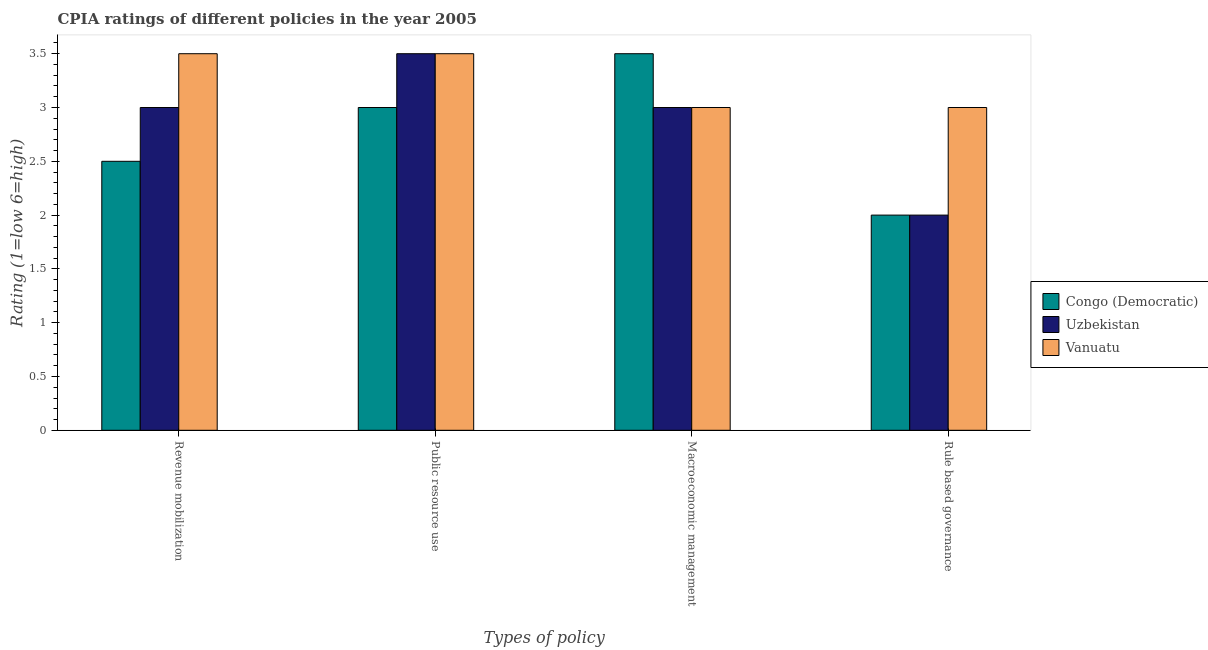Are the number of bars on each tick of the X-axis equal?
Give a very brief answer. Yes. How many bars are there on the 2nd tick from the right?
Your answer should be very brief. 3. What is the label of the 3rd group of bars from the left?
Ensure brevity in your answer.  Macroeconomic management. What is the cpia rating of revenue mobilization in Congo (Democratic)?
Keep it short and to the point. 2.5. Across all countries, what is the minimum cpia rating of revenue mobilization?
Your answer should be very brief. 2.5. In which country was the cpia rating of public resource use maximum?
Provide a short and direct response. Uzbekistan. In which country was the cpia rating of public resource use minimum?
Give a very brief answer. Congo (Democratic). What is the difference between the cpia rating of public resource use in Congo (Democratic) and that in Vanuatu?
Your answer should be compact. -0.5. What is the difference between the cpia rating of rule based governance in Vanuatu and the cpia rating of macroeconomic management in Congo (Democratic)?
Your answer should be compact. -0.5. What is the average cpia rating of rule based governance per country?
Ensure brevity in your answer.  2.33. What is the ratio of the cpia rating of rule based governance in Uzbekistan to that in Vanuatu?
Offer a very short reply. 0.67. What is the difference between the highest and the second highest cpia rating of public resource use?
Your response must be concise. 0. What is the difference between the highest and the lowest cpia rating of public resource use?
Offer a terse response. 0.5. In how many countries, is the cpia rating of public resource use greater than the average cpia rating of public resource use taken over all countries?
Offer a very short reply. 2. What does the 2nd bar from the left in Public resource use represents?
Offer a very short reply. Uzbekistan. What does the 1st bar from the right in Rule based governance represents?
Your response must be concise. Vanuatu. How many bars are there?
Offer a terse response. 12. How many countries are there in the graph?
Provide a succinct answer. 3. What is the difference between two consecutive major ticks on the Y-axis?
Your response must be concise. 0.5. Does the graph contain grids?
Give a very brief answer. No. How many legend labels are there?
Ensure brevity in your answer.  3. How are the legend labels stacked?
Offer a very short reply. Vertical. What is the title of the graph?
Give a very brief answer. CPIA ratings of different policies in the year 2005. Does "Czech Republic" appear as one of the legend labels in the graph?
Offer a terse response. No. What is the label or title of the X-axis?
Ensure brevity in your answer.  Types of policy. What is the Rating (1=low 6=high) of Congo (Democratic) in Revenue mobilization?
Your response must be concise. 2.5. What is the Rating (1=low 6=high) in Congo (Democratic) in Public resource use?
Ensure brevity in your answer.  3. What is the Rating (1=low 6=high) in Congo (Democratic) in Macroeconomic management?
Provide a succinct answer. 3.5. What is the Rating (1=low 6=high) of Uzbekistan in Rule based governance?
Give a very brief answer. 2. Across all Types of policy, what is the maximum Rating (1=low 6=high) in Congo (Democratic)?
Make the answer very short. 3.5. Across all Types of policy, what is the maximum Rating (1=low 6=high) in Vanuatu?
Your response must be concise. 3.5. Across all Types of policy, what is the minimum Rating (1=low 6=high) of Congo (Democratic)?
Provide a succinct answer. 2. Across all Types of policy, what is the minimum Rating (1=low 6=high) in Uzbekistan?
Your response must be concise. 2. Across all Types of policy, what is the minimum Rating (1=low 6=high) of Vanuatu?
Provide a short and direct response. 3. What is the difference between the Rating (1=low 6=high) of Congo (Democratic) in Revenue mobilization and that in Public resource use?
Offer a very short reply. -0.5. What is the difference between the Rating (1=low 6=high) of Congo (Democratic) in Revenue mobilization and that in Macroeconomic management?
Offer a very short reply. -1. What is the difference between the Rating (1=low 6=high) of Vanuatu in Revenue mobilization and that in Macroeconomic management?
Offer a very short reply. 0.5. What is the difference between the Rating (1=low 6=high) in Congo (Democratic) in Revenue mobilization and that in Rule based governance?
Provide a short and direct response. 0.5. What is the difference between the Rating (1=low 6=high) of Vanuatu in Revenue mobilization and that in Rule based governance?
Give a very brief answer. 0.5. What is the difference between the Rating (1=low 6=high) of Congo (Democratic) in Public resource use and that in Macroeconomic management?
Provide a short and direct response. -0.5. What is the difference between the Rating (1=low 6=high) of Vanuatu in Public resource use and that in Macroeconomic management?
Your response must be concise. 0.5. What is the difference between the Rating (1=low 6=high) of Congo (Democratic) in Public resource use and that in Rule based governance?
Your answer should be compact. 1. What is the difference between the Rating (1=low 6=high) in Uzbekistan in Public resource use and that in Rule based governance?
Ensure brevity in your answer.  1.5. What is the difference between the Rating (1=low 6=high) in Vanuatu in Public resource use and that in Rule based governance?
Make the answer very short. 0.5. What is the difference between the Rating (1=low 6=high) of Congo (Democratic) in Macroeconomic management and that in Rule based governance?
Your answer should be very brief. 1.5. What is the difference between the Rating (1=low 6=high) of Uzbekistan in Macroeconomic management and that in Rule based governance?
Provide a short and direct response. 1. What is the difference between the Rating (1=low 6=high) in Vanuatu in Macroeconomic management and that in Rule based governance?
Offer a very short reply. 0. What is the difference between the Rating (1=low 6=high) of Uzbekistan in Revenue mobilization and the Rating (1=low 6=high) of Vanuatu in Public resource use?
Make the answer very short. -0.5. What is the difference between the Rating (1=low 6=high) in Congo (Democratic) in Revenue mobilization and the Rating (1=low 6=high) in Uzbekistan in Macroeconomic management?
Ensure brevity in your answer.  -0.5. What is the difference between the Rating (1=low 6=high) in Congo (Democratic) in Revenue mobilization and the Rating (1=low 6=high) in Vanuatu in Macroeconomic management?
Keep it short and to the point. -0.5. What is the difference between the Rating (1=low 6=high) in Uzbekistan in Revenue mobilization and the Rating (1=low 6=high) in Vanuatu in Macroeconomic management?
Provide a short and direct response. 0. What is the difference between the Rating (1=low 6=high) in Congo (Democratic) in Revenue mobilization and the Rating (1=low 6=high) in Uzbekistan in Rule based governance?
Your answer should be very brief. 0.5. What is the difference between the Rating (1=low 6=high) of Congo (Democratic) in Public resource use and the Rating (1=low 6=high) of Uzbekistan in Macroeconomic management?
Your response must be concise. 0. What is the difference between the Rating (1=low 6=high) of Congo (Democratic) in Public resource use and the Rating (1=low 6=high) of Vanuatu in Macroeconomic management?
Provide a succinct answer. 0. What is the average Rating (1=low 6=high) in Congo (Democratic) per Types of policy?
Make the answer very short. 2.75. What is the average Rating (1=low 6=high) of Uzbekistan per Types of policy?
Your answer should be compact. 2.88. What is the difference between the Rating (1=low 6=high) of Congo (Democratic) and Rating (1=low 6=high) of Uzbekistan in Public resource use?
Your response must be concise. -0.5. What is the difference between the Rating (1=low 6=high) of Uzbekistan and Rating (1=low 6=high) of Vanuatu in Public resource use?
Provide a succinct answer. 0. What is the difference between the Rating (1=low 6=high) in Congo (Democratic) and Rating (1=low 6=high) in Uzbekistan in Macroeconomic management?
Provide a short and direct response. 0.5. What is the difference between the Rating (1=low 6=high) of Uzbekistan and Rating (1=low 6=high) of Vanuatu in Macroeconomic management?
Make the answer very short. 0. What is the difference between the Rating (1=low 6=high) in Congo (Democratic) and Rating (1=low 6=high) in Vanuatu in Rule based governance?
Provide a succinct answer. -1. What is the difference between the Rating (1=low 6=high) of Uzbekistan and Rating (1=low 6=high) of Vanuatu in Rule based governance?
Your answer should be very brief. -1. What is the ratio of the Rating (1=low 6=high) in Congo (Democratic) in Revenue mobilization to that in Public resource use?
Provide a succinct answer. 0.83. What is the ratio of the Rating (1=low 6=high) in Uzbekistan in Revenue mobilization to that in Public resource use?
Give a very brief answer. 0.86. What is the ratio of the Rating (1=low 6=high) in Vanuatu in Revenue mobilization to that in Public resource use?
Your response must be concise. 1. What is the ratio of the Rating (1=low 6=high) of Congo (Democratic) in Revenue mobilization to that in Rule based governance?
Provide a succinct answer. 1.25. What is the ratio of the Rating (1=low 6=high) of Uzbekistan in Revenue mobilization to that in Rule based governance?
Make the answer very short. 1.5. What is the ratio of the Rating (1=low 6=high) of Vanuatu in Revenue mobilization to that in Rule based governance?
Provide a succinct answer. 1.17. What is the ratio of the Rating (1=low 6=high) in Congo (Democratic) in Public resource use to that in Macroeconomic management?
Ensure brevity in your answer.  0.86. What is the ratio of the Rating (1=low 6=high) in Uzbekistan in Public resource use to that in Macroeconomic management?
Your response must be concise. 1.17. What is the ratio of the Rating (1=low 6=high) in Congo (Democratic) in Public resource use to that in Rule based governance?
Your answer should be compact. 1.5. What is the ratio of the Rating (1=low 6=high) of Uzbekistan in Public resource use to that in Rule based governance?
Offer a terse response. 1.75. What is the difference between the highest and the second highest Rating (1=low 6=high) in Congo (Democratic)?
Keep it short and to the point. 0.5. What is the difference between the highest and the second highest Rating (1=low 6=high) in Uzbekistan?
Your answer should be very brief. 0.5. What is the difference between the highest and the second highest Rating (1=low 6=high) of Vanuatu?
Ensure brevity in your answer.  0. 